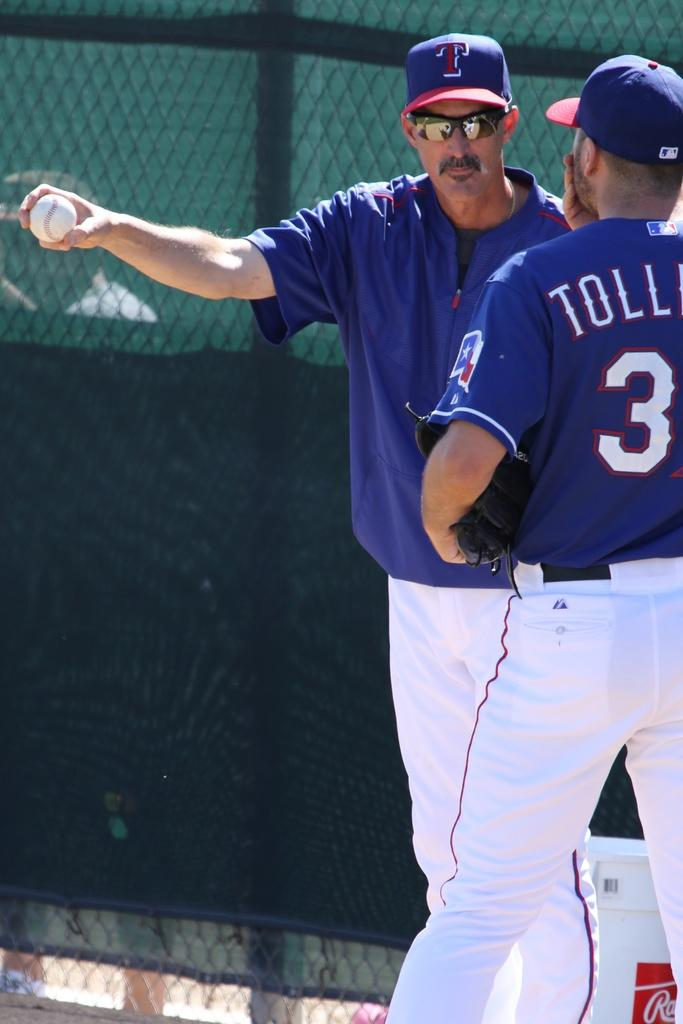Provide a one-sentence caption for the provided image. Two men in Texas baseball uniforms are standing next to each other. 